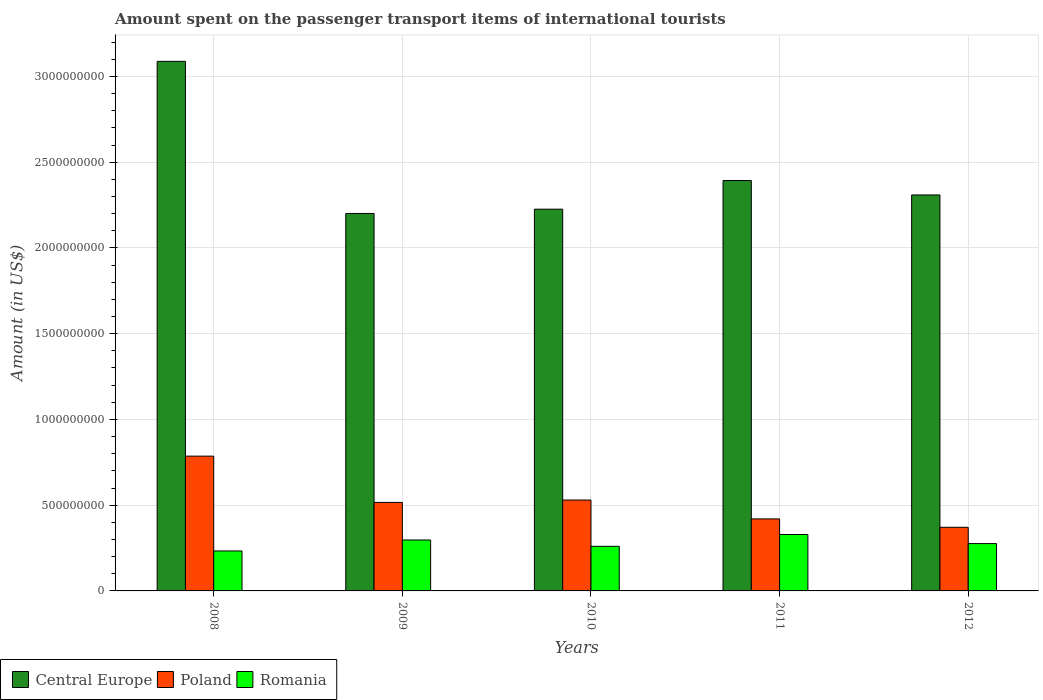How many different coloured bars are there?
Offer a very short reply. 3. Are the number of bars per tick equal to the number of legend labels?
Provide a succinct answer. Yes. Are the number of bars on each tick of the X-axis equal?
Your answer should be very brief. Yes. In how many cases, is the number of bars for a given year not equal to the number of legend labels?
Your answer should be compact. 0. What is the amount spent on the passenger transport items of international tourists in Poland in 2010?
Provide a succinct answer. 5.30e+08. Across all years, what is the maximum amount spent on the passenger transport items of international tourists in Central Europe?
Offer a terse response. 3.09e+09. Across all years, what is the minimum amount spent on the passenger transport items of international tourists in Romania?
Your response must be concise. 2.33e+08. In which year was the amount spent on the passenger transport items of international tourists in Poland minimum?
Provide a short and direct response. 2012. What is the total amount spent on the passenger transport items of international tourists in Central Europe in the graph?
Your answer should be very brief. 1.22e+1. What is the difference between the amount spent on the passenger transport items of international tourists in Romania in 2010 and that in 2012?
Provide a succinct answer. -1.60e+07. What is the difference between the amount spent on the passenger transport items of international tourists in Romania in 2008 and the amount spent on the passenger transport items of international tourists in Poland in 2012?
Offer a very short reply. -1.38e+08. What is the average amount spent on the passenger transport items of international tourists in Romania per year?
Give a very brief answer. 2.79e+08. In the year 2011, what is the difference between the amount spent on the passenger transport items of international tourists in Poland and amount spent on the passenger transport items of international tourists in Central Europe?
Offer a very short reply. -1.97e+09. In how many years, is the amount spent on the passenger transport items of international tourists in Central Europe greater than 1200000000 US$?
Your answer should be compact. 5. What is the ratio of the amount spent on the passenger transport items of international tourists in Poland in 2008 to that in 2012?
Keep it short and to the point. 2.12. Is the amount spent on the passenger transport items of international tourists in Romania in 2009 less than that in 2011?
Offer a very short reply. Yes. Is the difference between the amount spent on the passenger transport items of international tourists in Poland in 2008 and 2011 greater than the difference between the amount spent on the passenger transport items of international tourists in Central Europe in 2008 and 2011?
Provide a short and direct response. No. What is the difference between the highest and the second highest amount spent on the passenger transport items of international tourists in Central Europe?
Provide a succinct answer. 6.95e+08. What is the difference between the highest and the lowest amount spent on the passenger transport items of international tourists in Romania?
Your answer should be compact. 9.60e+07. In how many years, is the amount spent on the passenger transport items of international tourists in Central Europe greater than the average amount spent on the passenger transport items of international tourists in Central Europe taken over all years?
Offer a very short reply. 1. Is the sum of the amount spent on the passenger transport items of international tourists in Romania in 2010 and 2011 greater than the maximum amount spent on the passenger transport items of international tourists in Central Europe across all years?
Keep it short and to the point. No. What does the 1st bar from the left in 2009 represents?
Make the answer very short. Central Europe. What does the 1st bar from the right in 2012 represents?
Offer a very short reply. Romania. Is it the case that in every year, the sum of the amount spent on the passenger transport items of international tourists in Poland and amount spent on the passenger transport items of international tourists in Romania is greater than the amount spent on the passenger transport items of international tourists in Central Europe?
Offer a terse response. No. Are all the bars in the graph horizontal?
Provide a succinct answer. No. How many years are there in the graph?
Ensure brevity in your answer.  5. What is the difference between two consecutive major ticks on the Y-axis?
Your answer should be compact. 5.00e+08. Are the values on the major ticks of Y-axis written in scientific E-notation?
Your response must be concise. No. Does the graph contain grids?
Keep it short and to the point. Yes. How many legend labels are there?
Your answer should be very brief. 3. How are the legend labels stacked?
Offer a very short reply. Horizontal. What is the title of the graph?
Your response must be concise. Amount spent on the passenger transport items of international tourists. Does "Honduras" appear as one of the legend labels in the graph?
Provide a succinct answer. No. What is the label or title of the X-axis?
Your answer should be very brief. Years. What is the Amount (in US$) in Central Europe in 2008?
Your answer should be compact. 3.09e+09. What is the Amount (in US$) in Poland in 2008?
Keep it short and to the point. 7.86e+08. What is the Amount (in US$) in Romania in 2008?
Keep it short and to the point. 2.33e+08. What is the Amount (in US$) in Central Europe in 2009?
Ensure brevity in your answer.  2.20e+09. What is the Amount (in US$) in Poland in 2009?
Offer a terse response. 5.16e+08. What is the Amount (in US$) of Romania in 2009?
Offer a very short reply. 2.97e+08. What is the Amount (in US$) of Central Europe in 2010?
Make the answer very short. 2.23e+09. What is the Amount (in US$) in Poland in 2010?
Keep it short and to the point. 5.30e+08. What is the Amount (in US$) of Romania in 2010?
Your answer should be compact. 2.60e+08. What is the Amount (in US$) in Central Europe in 2011?
Your answer should be very brief. 2.39e+09. What is the Amount (in US$) of Poland in 2011?
Your response must be concise. 4.20e+08. What is the Amount (in US$) in Romania in 2011?
Offer a very short reply. 3.29e+08. What is the Amount (in US$) in Central Europe in 2012?
Your answer should be very brief. 2.31e+09. What is the Amount (in US$) of Poland in 2012?
Offer a terse response. 3.71e+08. What is the Amount (in US$) in Romania in 2012?
Keep it short and to the point. 2.76e+08. Across all years, what is the maximum Amount (in US$) of Central Europe?
Provide a short and direct response. 3.09e+09. Across all years, what is the maximum Amount (in US$) in Poland?
Make the answer very short. 7.86e+08. Across all years, what is the maximum Amount (in US$) in Romania?
Give a very brief answer. 3.29e+08. Across all years, what is the minimum Amount (in US$) of Central Europe?
Offer a terse response. 2.20e+09. Across all years, what is the minimum Amount (in US$) of Poland?
Ensure brevity in your answer.  3.71e+08. Across all years, what is the minimum Amount (in US$) of Romania?
Give a very brief answer. 2.33e+08. What is the total Amount (in US$) of Central Europe in the graph?
Your answer should be very brief. 1.22e+1. What is the total Amount (in US$) of Poland in the graph?
Provide a succinct answer. 2.62e+09. What is the total Amount (in US$) of Romania in the graph?
Your answer should be very brief. 1.40e+09. What is the difference between the Amount (in US$) in Central Europe in 2008 and that in 2009?
Your answer should be compact. 8.87e+08. What is the difference between the Amount (in US$) in Poland in 2008 and that in 2009?
Give a very brief answer. 2.70e+08. What is the difference between the Amount (in US$) in Romania in 2008 and that in 2009?
Your answer should be compact. -6.40e+07. What is the difference between the Amount (in US$) of Central Europe in 2008 and that in 2010?
Ensure brevity in your answer.  8.62e+08. What is the difference between the Amount (in US$) in Poland in 2008 and that in 2010?
Keep it short and to the point. 2.56e+08. What is the difference between the Amount (in US$) of Romania in 2008 and that in 2010?
Offer a terse response. -2.70e+07. What is the difference between the Amount (in US$) in Central Europe in 2008 and that in 2011?
Make the answer very short. 6.95e+08. What is the difference between the Amount (in US$) of Poland in 2008 and that in 2011?
Ensure brevity in your answer.  3.66e+08. What is the difference between the Amount (in US$) in Romania in 2008 and that in 2011?
Give a very brief answer. -9.60e+07. What is the difference between the Amount (in US$) of Central Europe in 2008 and that in 2012?
Your answer should be compact. 7.79e+08. What is the difference between the Amount (in US$) of Poland in 2008 and that in 2012?
Your response must be concise. 4.15e+08. What is the difference between the Amount (in US$) in Romania in 2008 and that in 2012?
Offer a terse response. -4.30e+07. What is the difference between the Amount (in US$) of Central Europe in 2009 and that in 2010?
Provide a short and direct response. -2.50e+07. What is the difference between the Amount (in US$) of Poland in 2009 and that in 2010?
Your answer should be very brief. -1.40e+07. What is the difference between the Amount (in US$) in Romania in 2009 and that in 2010?
Ensure brevity in your answer.  3.70e+07. What is the difference between the Amount (in US$) of Central Europe in 2009 and that in 2011?
Offer a very short reply. -1.92e+08. What is the difference between the Amount (in US$) in Poland in 2009 and that in 2011?
Offer a very short reply. 9.60e+07. What is the difference between the Amount (in US$) in Romania in 2009 and that in 2011?
Your answer should be compact. -3.20e+07. What is the difference between the Amount (in US$) in Central Europe in 2009 and that in 2012?
Your answer should be very brief. -1.08e+08. What is the difference between the Amount (in US$) in Poland in 2009 and that in 2012?
Your answer should be compact. 1.45e+08. What is the difference between the Amount (in US$) in Romania in 2009 and that in 2012?
Make the answer very short. 2.10e+07. What is the difference between the Amount (in US$) in Central Europe in 2010 and that in 2011?
Keep it short and to the point. -1.67e+08. What is the difference between the Amount (in US$) of Poland in 2010 and that in 2011?
Give a very brief answer. 1.10e+08. What is the difference between the Amount (in US$) in Romania in 2010 and that in 2011?
Offer a very short reply. -6.90e+07. What is the difference between the Amount (in US$) in Central Europe in 2010 and that in 2012?
Give a very brief answer. -8.30e+07. What is the difference between the Amount (in US$) in Poland in 2010 and that in 2012?
Provide a succinct answer. 1.59e+08. What is the difference between the Amount (in US$) in Romania in 2010 and that in 2012?
Ensure brevity in your answer.  -1.60e+07. What is the difference between the Amount (in US$) of Central Europe in 2011 and that in 2012?
Your answer should be compact. 8.40e+07. What is the difference between the Amount (in US$) in Poland in 2011 and that in 2012?
Provide a succinct answer. 4.90e+07. What is the difference between the Amount (in US$) in Romania in 2011 and that in 2012?
Ensure brevity in your answer.  5.30e+07. What is the difference between the Amount (in US$) of Central Europe in 2008 and the Amount (in US$) of Poland in 2009?
Offer a very short reply. 2.57e+09. What is the difference between the Amount (in US$) in Central Europe in 2008 and the Amount (in US$) in Romania in 2009?
Make the answer very short. 2.79e+09. What is the difference between the Amount (in US$) in Poland in 2008 and the Amount (in US$) in Romania in 2009?
Provide a succinct answer. 4.89e+08. What is the difference between the Amount (in US$) of Central Europe in 2008 and the Amount (in US$) of Poland in 2010?
Provide a short and direct response. 2.56e+09. What is the difference between the Amount (in US$) of Central Europe in 2008 and the Amount (in US$) of Romania in 2010?
Your response must be concise. 2.83e+09. What is the difference between the Amount (in US$) of Poland in 2008 and the Amount (in US$) of Romania in 2010?
Make the answer very short. 5.26e+08. What is the difference between the Amount (in US$) in Central Europe in 2008 and the Amount (in US$) in Poland in 2011?
Offer a very short reply. 2.67e+09. What is the difference between the Amount (in US$) of Central Europe in 2008 and the Amount (in US$) of Romania in 2011?
Keep it short and to the point. 2.76e+09. What is the difference between the Amount (in US$) in Poland in 2008 and the Amount (in US$) in Romania in 2011?
Make the answer very short. 4.57e+08. What is the difference between the Amount (in US$) of Central Europe in 2008 and the Amount (in US$) of Poland in 2012?
Keep it short and to the point. 2.72e+09. What is the difference between the Amount (in US$) of Central Europe in 2008 and the Amount (in US$) of Romania in 2012?
Offer a terse response. 2.81e+09. What is the difference between the Amount (in US$) of Poland in 2008 and the Amount (in US$) of Romania in 2012?
Provide a succinct answer. 5.10e+08. What is the difference between the Amount (in US$) of Central Europe in 2009 and the Amount (in US$) of Poland in 2010?
Ensure brevity in your answer.  1.67e+09. What is the difference between the Amount (in US$) of Central Europe in 2009 and the Amount (in US$) of Romania in 2010?
Ensure brevity in your answer.  1.94e+09. What is the difference between the Amount (in US$) in Poland in 2009 and the Amount (in US$) in Romania in 2010?
Provide a succinct answer. 2.56e+08. What is the difference between the Amount (in US$) in Central Europe in 2009 and the Amount (in US$) in Poland in 2011?
Give a very brief answer. 1.78e+09. What is the difference between the Amount (in US$) of Central Europe in 2009 and the Amount (in US$) of Romania in 2011?
Offer a very short reply. 1.87e+09. What is the difference between the Amount (in US$) of Poland in 2009 and the Amount (in US$) of Romania in 2011?
Your response must be concise. 1.87e+08. What is the difference between the Amount (in US$) in Central Europe in 2009 and the Amount (in US$) in Poland in 2012?
Your answer should be compact. 1.83e+09. What is the difference between the Amount (in US$) of Central Europe in 2009 and the Amount (in US$) of Romania in 2012?
Your response must be concise. 1.92e+09. What is the difference between the Amount (in US$) in Poland in 2009 and the Amount (in US$) in Romania in 2012?
Make the answer very short. 2.40e+08. What is the difference between the Amount (in US$) of Central Europe in 2010 and the Amount (in US$) of Poland in 2011?
Offer a terse response. 1.81e+09. What is the difference between the Amount (in US$) in Central Europe in 2010 and the Amount (in US$) in Romania in 2011?
Your answer should be very brief. 1.90e+09. What is the difference between the Amount (in US$) in Poland in 2010 and the Amount (in US$) in Romania in 2011?
Make the answer very short. 2.01e+08. What is the difference between the Amount (in US$) of Central Europe in 2010 and the Amount (in US$) of Poland in 2012?
Make the answer very short. 1.86e+09. What is the difference between the Amount (in US$) of Central Europe in 2010 and the Amount (in US$) of Romania in 2012?
Provide a succinct answer. 1.95e+09. What is the difference between the Amount (in US$) of Poland in 2010 and the Amount (in US$) of Romania in 2012?
Your answer should be compact. 2.54e+08. What is the difference between the Amount (in US$) in Central Europe in 2011 and the Amount (in US$) in Poland in 2012?
Provide a short and direct response. 2.02e+09. What is the difference between the Amount (in US$) of Central Europe in 2011 and the Amount (in US$) of Romania in 2012?
Keep it short and to the point. 2.12e+09. What is the difference between the Amount (in US$) of Poland in 2011 and the Amount (in US$) of Romania in 2012?
Your response must be concise. 1.44e+08. What is the average Amount (in US$) in Central Europe per year?
Your answer should be compact. 2.44e+09. What is the average Amount (in US$) of Poland per year?
Offer a very short reply. 5.25e+08. What is the average Amount (in US$) of Romania per year?
Provide a succinct answer. 2.79e+08. In the year 2008, what is the difference between the Amount (in US$) of Central Europe and Amount (in US$) of Poland?
Offer a very short reply. 2.30e+09. In the year 2008, what is the difference between the Amount (in US$) of Central Europe and Amount (in US$) of Romania?
Provide a succinct answer. 2.86e+09. In the year 2008, what is the difference between the Amount (in US$) of Poland and Amount (in US$) of Romania?
Your answer should be compact. 5.53e+08. In the year 2009, what is the difference between the Amount (in US$) in Central Europe and Amount (in US$) in Poland?
Give a very brief answer. 1.68e+09. In the year 2009, what is the difference between the Amount (in US$) in Central Europe and Amount (in US$) in Romania?
Give a very brief answer. 1.90e+09. In the year 2009, what is the difference between the Amount (in US$) in Poland and Amount (in US$) in Romania?
Give a very brief answer. 2.19e+08. In the year 2010, what is the difference between the Amount (in US$) of Central Europe and Amount (in US$) of Poland?
Your response must be concise. 1.70e+09. In the year 2010, what is the difference between the Amount (in US$) in Central Europe and Amount (in US$) in Romania?
Provide a short and direct response. 1.97e+09. In the year 2010, what is the difference between the Amount (in US$) of Poland and Amount (in US$) of Romania?
Your answer should be compact. 2.70e+08. In the year 2011, what is the difference between the Amount (in US$) in Central Europe and Amount (in US$) in Poland?
Give a very brief answer. 1.97e+09. In the year 2011, what is the difference between the Amount (in US$) of Central Europe and Amount (in US$) of Romania?
Keep it short and to the point. 2.06e+09. In the year 2011, what is the difference between the Amount (in US$) of Poland and Amount (in US$) of Romania?
Provide a short and direct response. 9.10e+07. In the year 2012, what is the difference between the Amount (in US$) in Central Europe and Amount (in US$) in Poland?
Make the answer very short. 1.94e+09. In the year 2012, what is the difference between the Amount (in US$) in Central Europe and Amount (in US$) in Romania?
Provide a short and direct response. 2.03e+09. In the year 2012, what is the difference between the Amount (in US$) in Poland and Amount (in US$) in Romania?
Ensure brevity in your answer.  9.50e+07. What is the ratio of the Amount (in US$) of Central Europe in 2008 to that in 2009?
Offer a very short reply. 1.4. What is the ratio of the Amount (in US$) of Poland in 2008 to that in 2009?
Your answer should be compact. 1.52. What is the ratio of the Amount (in US$) of Romania in 2008 to that in 2009?
Provide a short and direct response. 0.78. What is the ratio of the Amount (in US$) of Central Europe in 2008 to that in 2010?
Your response must be concise. 1.39. What is the ratio of the Amount (in US$) of Poland in 2008 to that in 2010?
Make the answer very short. 1.48. What is the ratio of the Amount (in US$) in Romania in 2008 to that in 2010?
Give a very brief answer. 0.9. What is the ratio of the Amount (in US$) in Central Europe in 2008 to that in 2011?
Make the answer very short. 1.29. What is the ratio of the Amount (in US$) of Poland in 2008 to that in 2011?
Ensure brevity in your answer.  1.87. What is the ratio of the Amount (in US$) of Romania in 2008 to that in 2011?
Offer a terse response. 0.71. What is the ratio of the Amount (in US$) in Central Europe in 2008 to that in 2012?
Keep it short and to the point. 1.34. What is the ratio of the Amount (in US$) in Poland in 2008 to that in 2012?
Keep it short and to the point. 2.12. What is the ratio of the Amount (in US$) of Romania in 2008 to that in 2012?
Your answer should be very brief. 0.84. What is the ratio of the Amount (in US$) of Central Europe in 2009 to that in 2010?
Provide a succinct answer. 0.99. What is the ratio of the Amount (in US$) of Poland in 2009 to that in 2010?
Your response must be concise. 0.97. What is the ratio of the Amount (in US$) of Romania in 2009 to that in 2010?
Keep it short and to the point. 1.14. What is the ratio of the Amount (in US$) of Central Europe in 2009 to that in 2011?
Offer a very short reply. 0.92. What is the ratio of the Amount (in US$) in Poland in 2009 to that in 2011?
Offer a terse response. 1.23. What is the ratio of the Amount (in US$) in Romania in 2009 to that in 2011?
Provide a short and direct response. 0.9. What is the ratio of the Amount (in US$) in Central Europe in 2009 to that in 2012?
Ensure brevity in your answer.  0.95. What is the ratio of the Amount (in US$) in Poland in 2009 to that in 2012?
Keep it short and to the point. 1.39. What is the ratio of the Amount (in US$) of Romania in 2009 to that in 2012?
Keep it short and to the point. 1.08. What is the ratio of the Amount (in US$) of Central Europe in 2010 to that in 2011?
Your answer should be very brief. 0.93. What is the ratio of the Amount (in US$) of Poland in 2010 to that in 2011?
Make the answer very short. 1.26. What is the ratio of the Amount (in US$) of Romania in 2010 to that in 2011?
Ensure brevity in your answer.  0.79. What is the ratio of the Amount (in US$) in Central Europe in 2010 to that in 2012?
Offer a terse response. 0.96. What is the ratio of the Amount (in US$) of Poland in 2010 to that in 2012?
Your answer should be compact. 1.43. What is the ratio of the Amount (in US$) of Romania in 2010 to that in 2012?
Offer a very short reply. 0.94. What is the ratio of the Amount (in US$) of Central Europe in 2011 to that in 2012?
Offer a very short reply. 1.04. What is the ratio of the Amount (in US$) in Poland in 2011 to that in 2012?
Your answer should be very brief. 1.13. What is the ratio of the Amount (in US$) of Romania in 2011 to that in 2012?
Ensure brevity in your answer.  1.19. What is the difference between the highest and the second highest Amount (in US$) in Central Europe?
Your answer should be compact. 6.95e+08. What is the difference between the highest and the second highest Amount (in US$) in Poland?
Offer a terse response. 2.56e+08. What is the difference between the highest and the second highest Amount (in US$) of Romania?
Offer a terse response. 3.20e+07. What is the difference between the highest and the lowest Amount (in US$) of Central Europe?
Your response must be concise. 8.87e+08. What is the difference between the highest and the lowest Amount (in US$) in Poland?
Provide a succinct answer. 4.15e+08. What is the difference between the highest and the lowest Amount (in US$) in Romania?
Offer a very short reply. 9.60e+07. 